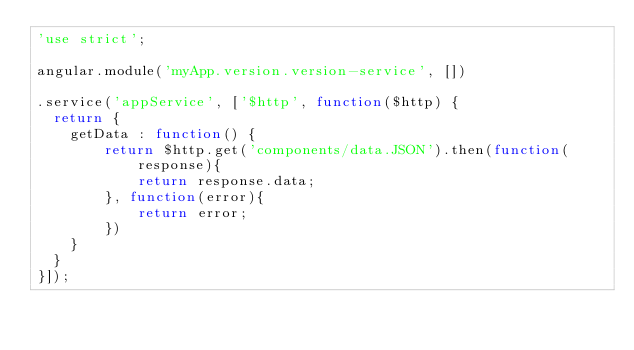<code> <loc_0><loc_0><loc_500><loc_500><_JavaScript_>'use strict';

angular.module('myApp.version.version-service', [])

.service('appService', ['$http', function($http) {
  return {
	getData : function() {
		return $http.get('components/data.JSON').then(function(response){
			return response.data;
		}, function(error){
			return error;
		})
	}
  }
}]);
</code> 